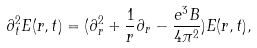Convert formula to latex. <formula><loc_0><loc_0><loc_500><loc_500>\partial _ { t } ^ { 2 } E ( r , t ) = ( \partial _ { r } ^ { 2 } + \frac { 1 } { r } \partial _ { r } - \frac { e ^ { 3 } B } { 4 \pi ^ { 2 } } ) E ( r , t ) ,</formula> 